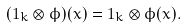<formula> <loc_0><loc_0><loc_500><loc_500>( 1 _ { k } \otimes \phi ) ( x ) = 1 _ { k } \otimes \phi ( x ) .</formula> 